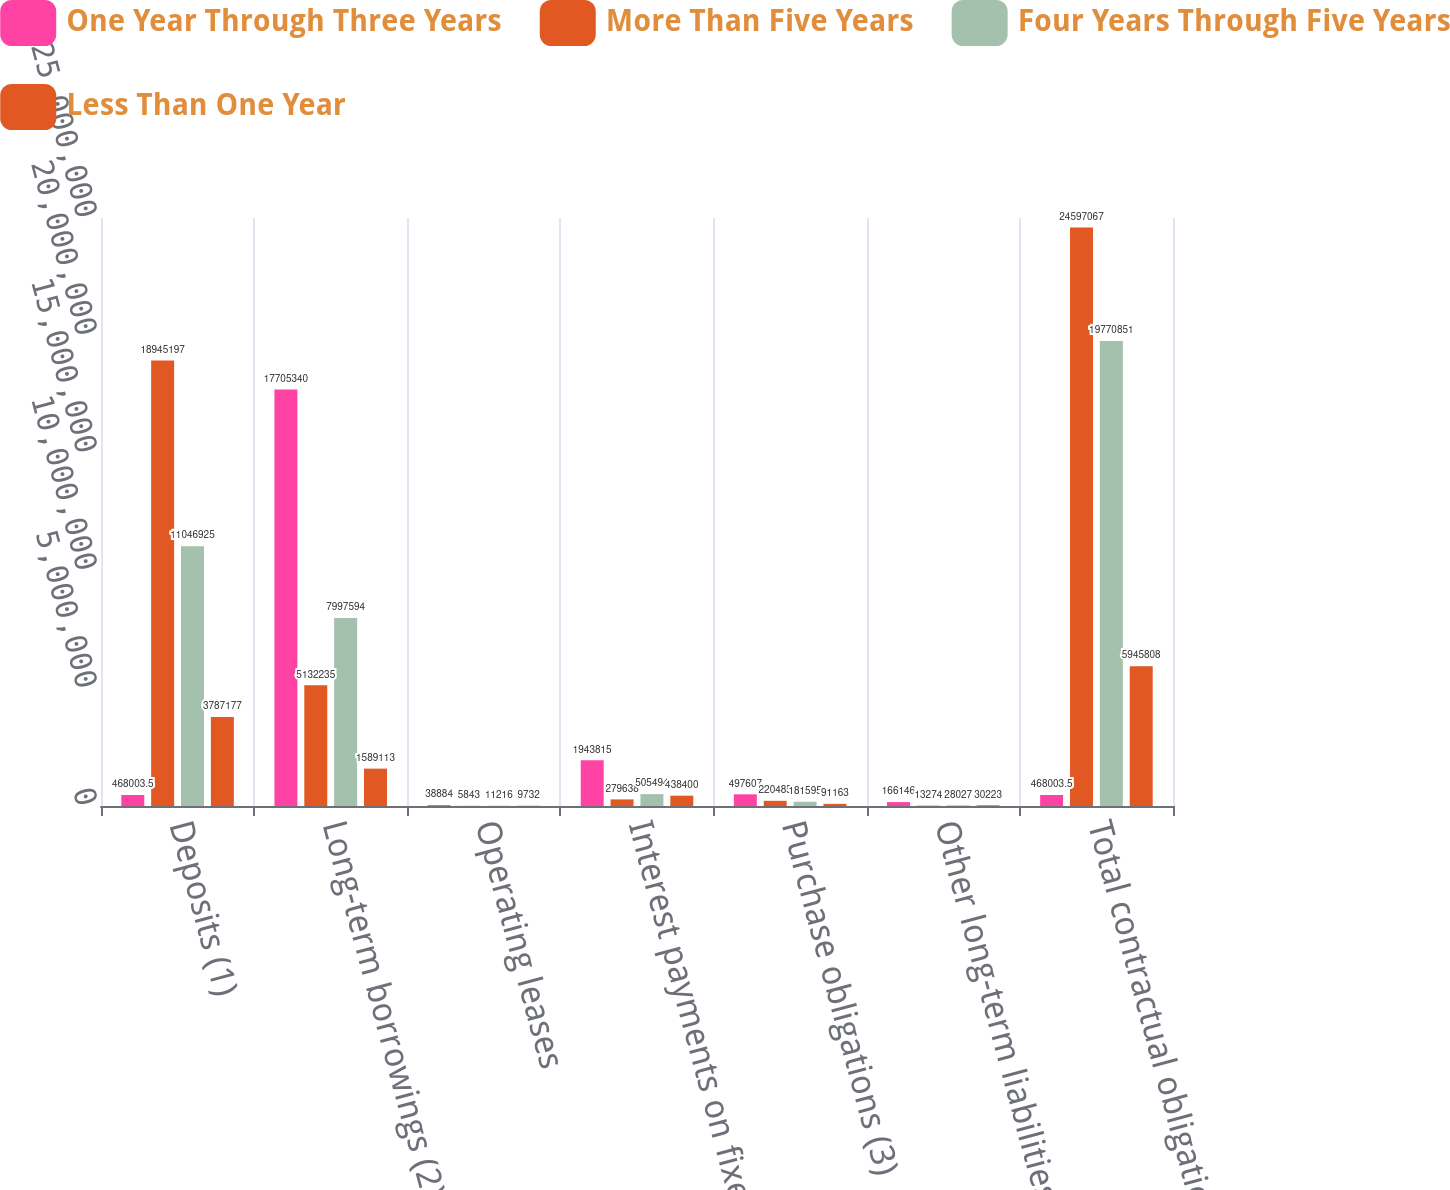Convert chart. <chart><loc_0><loc_0><loc_500><loc_500><stacked_bar_chart><ecel><fcel>Deposits (1)<fcel>Long-term borrowings (2)<fcel>Operating leases<fcel>Interest payments on fixed<fcel>Purchase obligations (3)<fcel>Other long-term liabilities<fcel>Total contractual obligations<nl><fcel>One Year Through Three Years<fcel>468004<fcel>1.77053e+07<fcel>38884<fcel>1.94382e+06<fcel>497607<fcel>166146<fcel>468004<nl><fcel>More Than Five Years<fcel>1.89452e+07<fcel>5.13224e+06<fcel>5843<fcel>279638<fcel>220485<fcel>13274<fcel>2.45971e+07<nl><fcel>Four Years Through Five Years<fcel>1.10469e+07<fcel>7.99759e+06<fcel>11216<fcel>505494<fcel>181595<fcel>28027<fcel>1.97709e+07<nl><fcel>Less Than One Year<fcel>3.78718e+06<fcel>1.58911e+06<fcel>9732<fcel>438400<fcel>91163<fcel>30223<fcel>5.94581e+06<nl></chart> 